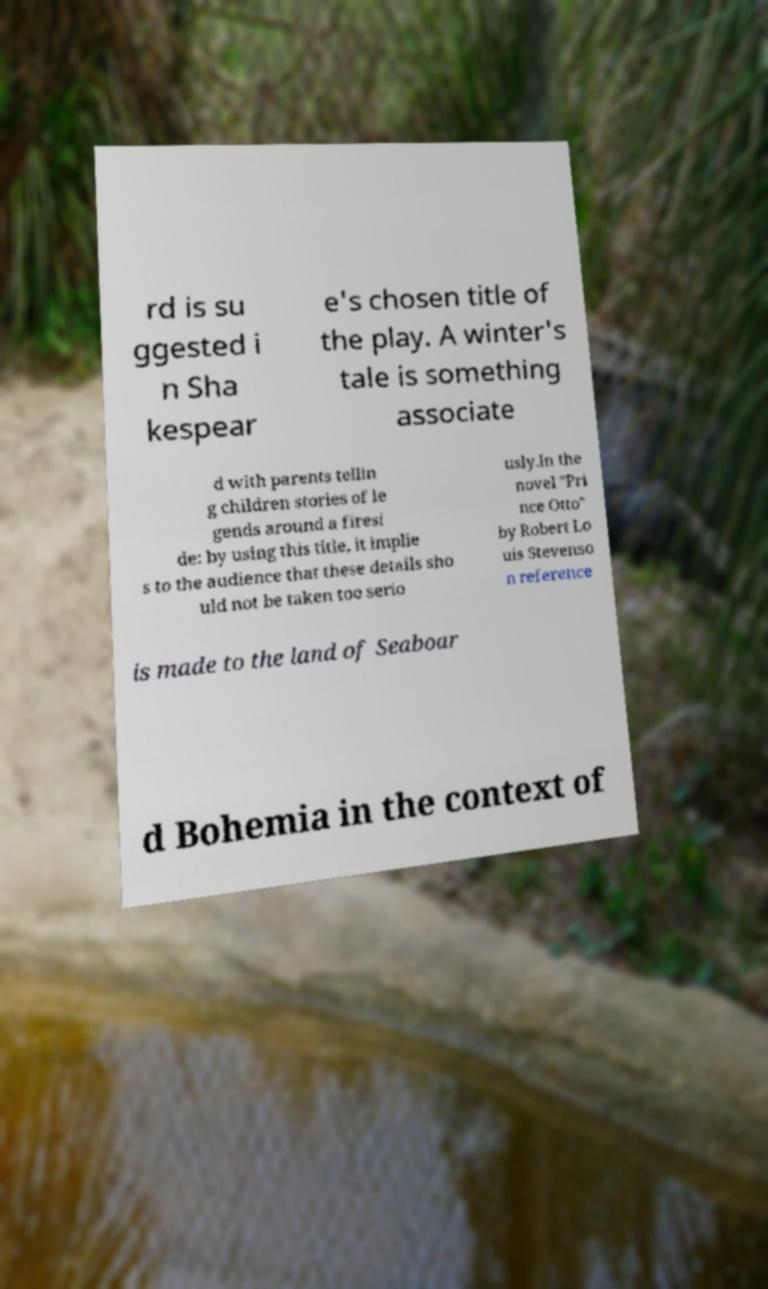For documentation purposes, I need the text within this image transcribed. Could you provide that? rd is su ggested i n Sha kespear e's chosen title of the play. A winter's tale is something associate d with parents tellin g children stories of le gends around a firesi de: by using this title, it implie s to the audience that these details sho uld not be taken too serio usly.In the novel "Pri nce Otto" by Robert Lo uis Stevenso n reference is made to the land of Seaboar d Bohemia in the context of 